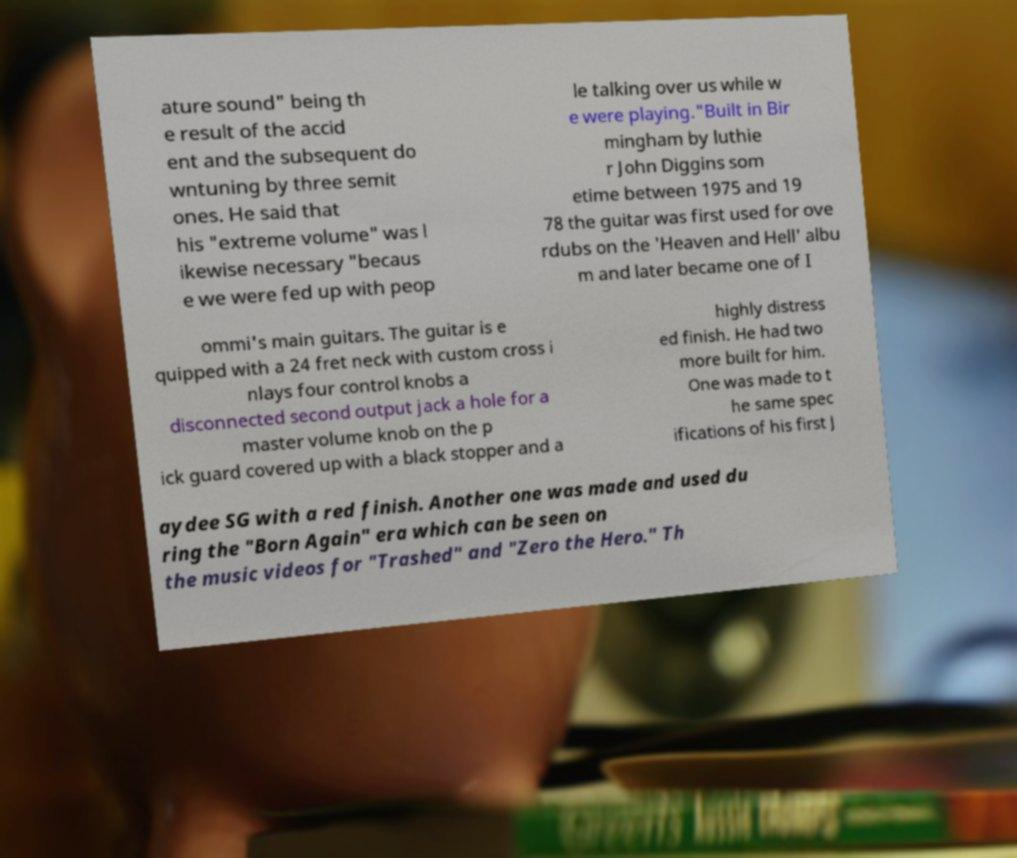What messages or text are displayed in this image? I need them in a readable, typed format. ature sound" being th e result of the accid ent and the subsequent do wntuning by three semit ones. He said that his "extreme volume" was l ikewise necessary "becaus e we were fed up with peop le talking over us while w e were playing."Built in Bir mingham by luthie r John Diggins som etime between 1975 and 19 78 the guitar was first used for ove rdubs on the 'Heaven and Hell' albu m and later became one of I ommi's main guitars. The guitar is e quipped with a 24 fret neck with custom cross i nlays four control knobs a disconnected second output jack a hole for a master volume knob on the p ick guard covered up with a black stopper and a highly distress ed finish. He had two more built for him. One was made to t he same spec ifications of his first J aydee SG with a red finish. Another one was made and used du ring the "Born Again" era which can be seen on the music videos for "Trashed" and "Zero the Hero." Th 